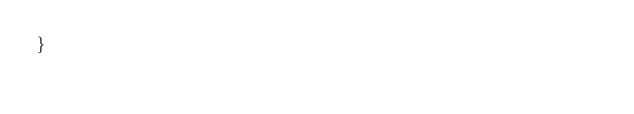Convert code to text. <code><loc_0><loc_0><loc_500><loc_500><_CSS_>}
</code> 